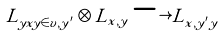Convert formula to latex. <formula><loc_0><loc_0><loc_500><loc_500>L _ { y x y \in v , y ^ { \prime } } \otimes L _ { x , y } \longrightarrow L _ { x , y ^ { \prime } y }</formula> 